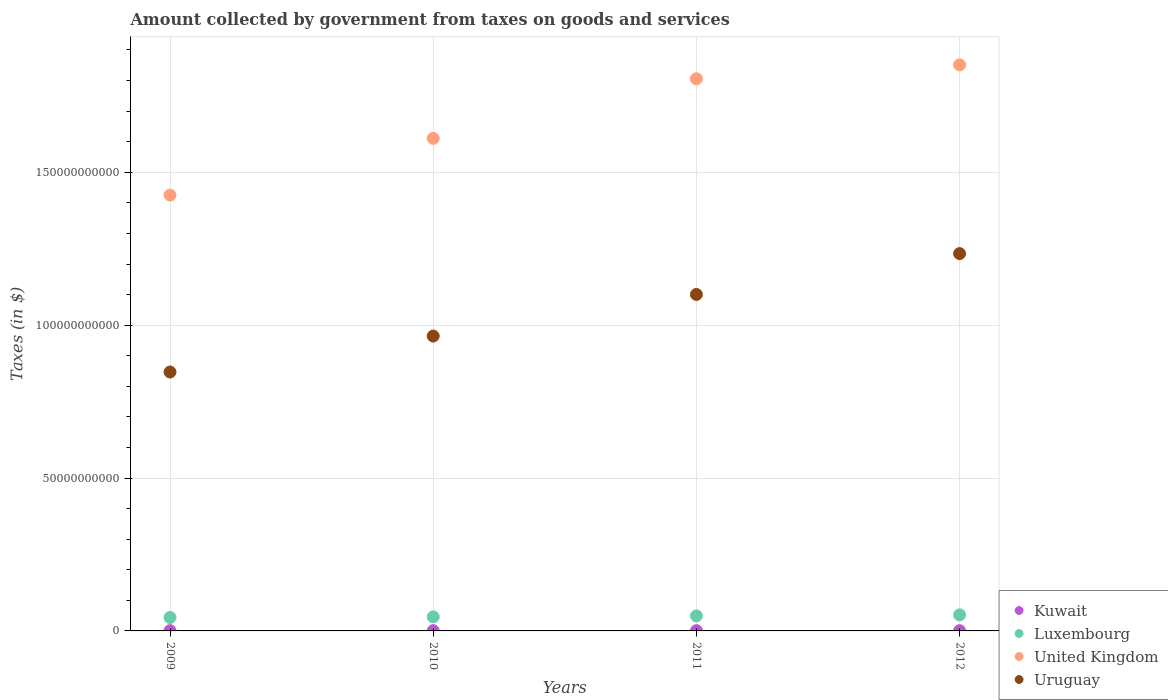What is the amount collected by government from taxes on goods and services in United Kingdom in 2011?
Make the answer very short. 1.81e+11. Across all years, what is the maximum amount collected by government from taxes on goods and services in Kuwait?
Offer a very short reply. 9.40e+07. Across all years, what is the minimum amount collected by government from taxes on goods and services in Kuwait?
Provide a short and direct response. 7.40e+07. In which year was the amount collected by government from taxes on goods and services in Luxembourg maximum?
Your response must be concise. 2012. In which year was the amount collected by government from taxes on goods and services in United Kingdom minimum?
Ensure brevity in your answer.  2009. What is the total amount collected by government from taxes on goods and services in United Kingdom in the graph?
Offer a terse response. 6.69e+11. What is the difference between the amount collected by government from taxes on goods and services in Uruguay in 2010 and that in 2012?
Your answer should be very brief. -2.70e+1. What is the difference between the amount collected by government from taxes on goods and services in Kuwait in 2011 and the amount collected by government from taxes on goods and services in United Kingdom in 2010?
Offer a terse response. -1.61e+11. What is the average amount collected by government from taxes on goods and services in Kuwait per year?
Provide a succinct answer. 8.55e+07. In the year 2009, what is the difference between the amount collected by government from taxes on goods and services in Kuwait and amount collected by government from taxes on goods and services in Uruguay?
Give a very brief answer. -8.46e+1. What is the ratio of the amount collected by government from taxes on goods and services in Luxembourg in 2009 to that in 2011?
Keep it short and to the point. 0.89. Is the amount collected by government from taxes on goods and services in Luxembourg in 2009 less than that in 2012?
Your response must be concise. Yes. What is the difference between the highest and the second highest amount collected by government from taxes on goods and services in Uruguay?
Your response must be concise. 1.34e+1. What is the difference between the highest and the lowest amount collected by government from taxes on goods and services in Luxembourg?
Provide a short and direct response. 8.72e+08. In how many years, is the amount collected by government from taxes on goods and services in Kuwait greater than the average amount collected by government from taxes on goods and services in Kuwait taken over all years?
Keep it short and to the point. 3. Is it the case that in every year, the sum of the amount collected by government from taxes on goods and services in Luxembourg and amount collected by government from taxes on goods and services in Kuwait  is greater than the amount collected by government from taxes on goods and services in United Kingdom?
Your answer should be very brief. No. Does the amount collected by government from taxes on goods and services in United Kingdom monotonically increase over the years?
Your response must be concise. Yes. Is the amount collected by government from taxes on goods and services in Kuwait strictly greater than the amount collected by government from taxes on goods and services in United Kingdom over the years?
Give a very brief answer. No. Is the amount collected by government from taxes on goods and services in Luxembourg strictly less than the amount collected by government from taxes on goods and services in Uruguay over the years?
Keep it short and to the point. Yes. How many dotlines are there?
Your response must be concise. 4. How many years are there in the graph?
Offer a very short reply. 4. What is the difference between two consecutive major ticks on the Y-axis?
Give a very brief answer. 5.00e+1. Are the values on the major ticks of Y-axis written in scientific E-notation?
Give a very brief answer. No. Does the graph contain any zero values?
Provide a succinct answer. No. Where does the legend appear in the graph?
Ensure brevity in your answer.  Bottom right. How are the legend labels stacked?
Keep it short and to the point. Vertical. What is the title of the graph?
Your response must be concise. Amount collected by government from taxes on goods and services. Does "Morocco" appear as one of the legend labels in the graph?
Offer a terse response. No. What is the label or title of the X-axis?
Your answer should be very brief. Years. What is the label or title of the Y-axis?
Your answer should be very brief. Taxes (in $). What is the Taxes (in $) in Kuwait in 2009?
Give a very brief answer. 9.40e+07. What is the Taxes (in $) of Luxembourg in 2009?
Make the answer very short. 4.38e+09. What is the Taxes (in $) of United Kingdom in 2009?
Your answer should be very brief. 1.43e+11. What is the Taxes (in $) in Uruguay in 2009?
Your response must be concise. 8.47e+1. What is the Taxes (in $) of Kuwait in 2010?
Keep it short and to the point. 8.80e+07. What is the Taxes (in $) in Luxembourg in 2010?
Your answer should be compact. 4.60e+09. What is the Taxes (in $) of United Kingdom in 2010?
Your answer should be compact. 1.61e+11. What is the Taxes (in $) in Uruguay in 2010?
Provide a succinct answer. 9.64e+1. What is the Taxes (in $) of Kuwait in 2011?
Give a very brief answer. 8.60e+07. What is the Taxes (in $) in Luxembourg in 2011?
Offer a very short reply. 4.92e+09. What is the Taxes (in $) in United Kingdom in 2011?
Your answer should be very brief. 1.81e+11. What is the Taxes (in $) in Uruguay in 2011?
Provide a short and direct response. 1.10e+11. What is the Taxes (in $) in Kuwait in 2012?
Ensure brevity in your answer.  7.40e+07. What is the Taxes (in $) in Luxembourg in 2012?
Your answer should be very brief. 5.25e+09. What is the Taxes (in $) in United Kingdom in 2012?
Your answer should be very brief. 1.85e+11. What is the Taxes (in $) of Uruguay in 2012?
Your answer should be very brief. 1.23e+11. Across all years, what is the maximum Taxes (in $) in Kuwait?
Make the answer very short. 9.40e+07. Across all years, what is the maximum Taxes (in $) in Luxembourg?
Make the answer very short. 5.25e+09. Across all years, what is the maximum Taxes (in $) in United Kingdom?
Your answer should be very brief. 1.85e+11. Across all years, what is the maximum Taxes (in $) in Uruguay?
Make the answer very short. 1.23e+11. Across all years, what is the minimum Taxes (in $) of Kuwait?
Provide a short and direct response. 7.40e+07. Across all years, what is the minimum Taxes (in $) of Luxembourg?
Your response must be concise. 4.38e+09. Across all years, what is the minimum Taxes (in $) of United Kingdom?
Your response must be concise. 1.43e+11. Across all years, what is the minimum Taxes (in $) in Uruguay?
Provide a succinct answer. 8.47e+1. What is the total Taxes (in $) of Kuwait in the graph?
Offer a terse response. 3.42e+08. What is the total Taxes (in $) in Luxembourg in the graph?
Offer a very short reply. 1.92e+1. What is the total Taxes (in $) of United Kingdom in the graph?
Keep it short and to the point. 6.69e+11. What is the total Taxes (in $) in Uruguay in the graph?
Give a very brief answer. 4.15e+11. What is the difference between the Taxes (in $) of Luxembourg in 2009 and that in 2010?
Your answer should be very brief. -2.15e+08. What is the difference between the Taxes (in $) in United Kingdom in 2009 and that in 2010?
Ensure brevity in your answer.  -1.86e+1. What is the difference between the Taxes (in $) of Uruguay in 2009 and that in 2010?
Your answer should be very brief. -1.18e+1. What is the difference between the Taxes (in $) in Luxembourg in 2009 and that in 2011?
Give a very brief answer. -5.37e+08. What is the difference between the Taxes (in $) of United Kingdom in 2009 and that in 2011?
Make the answer very short. -3.80e+1. What is the difference between the Taxes (in $) of Uruguay in 2009 and that in 2011?
Ensure brevity in your answer.  -2.54e+1. What is the difference between the Taxes (in $) in Kuwait in 2009 and that in 2012?
Ensure brevity in your answer.  2.00e+07. What is the difference between the Taxes (in $) in Luxembourg in 2009 and that in 2012?
Ensure brevity in your answer.  -8.72e+08. What is the difference between the Taxes (in $) in United Kingdom in 2009 and that in 2012?
Keep it short and to the point. -4.26e+1. What is the difference between the Taxes (in $) in Uruguay in 2009 and that in 2012?
Make the answer very short. -3.87e+1. What is the difference between the Taxes (in $) of Luxembourg in 2010 and that in 2011?
Offer a terse response. -3.22e+08. What is the difference between the Taxes (in $) in United Kingdom in 2010 and that in 2011?
Provide a succinct answer. -1.95e+1. What is the difference between the Taxes (in $) in Uruguay in 2010 and that in 2011?
Your response must be concise. -1.36e+1. What is the difference between the Taxes (in $) of Kuwait in 2010 and that in 2012?
Provide a short and direct response. 1.40e+07. What is the difference between the Taxes (in $) of Luxembourg in 2010 and that in 2012?
Your answer should be very brief. -6.56e+08. What is the difference between the Taxes (in $) in United Kingdom in 2010 and that in 2012?
Offer a terse response. -2.40e+1. What is the difference between the Taxes (in $) of Uruguay in 2010 and that in 2012?
Give a very brief answer. -2.70e+1. What is the difference between the Taxes (in $) in Kuwait in 2011 and that in 2012?
Offer a terse response. 1.20e+07. What is the difference between the Taxes (in $) of Luxembourg in 2011 and that in 2012?
Offer a very short reply. -3.35e+08. What is the difference between the Taxes (in $) of United Kingdom in 2011 and that in 2012?
Your answer should be compact. -4.55e+09. What is the difference between the Taxes (in $) of Uruguay in 2011 and that in 2012?
Provide a succinct answer. -1.34e+1. What is the difference between the Taxes (in $) of Kuwait in 2009 and the Taxes (in $) of Luxembourg in 2010?
Ensure brevity in your answer.  -4.50e+09. What is the difference between the Taxes (in $) in Kuwait in 2009 and the Taxes (in $) in United Kingdom in 2010?
Make the answer very short. -1.61e+11. What is the difference between the Taxes (in $) in Kuwait in 2009 and the Taxes (in $) in Uruguay in 2010?
Give a very brief answer. -9.63e+1. What is the difference between the Taxes (in $) of Luxembourg in 2009 and the Taxes (in $) of United Kingdom in 2010?
Your answer should be very brief. -1.57e+11. What is the difference between the Taxes (in $) of Luxembourg in 2009 and the Taxes (in $) of Uruguay in 2010?
Offer a terse response. -9.21e+1. What is the difference between the Taxes (in $) of United Kingdom in 2009 and the Taxes (in $) of Uruguay in 2010?
Your answer should be compact. 4.61e+1. What is the difference between the Taxes (in $) in Kuwait in 2009 and the Taxes (in $) in Luxembourg in 2011?
Your answer should be very brief. -4.83e+09. What is the difference between the Taxes (in $) in Kuwait in 2009 and the Taxes (in $) in United Kingdom in 2011?
Your response must be concise. -1.80e+11. What is the difference between the Taxes (in $) in Kuwait in 2009 and the Taxes (in $) in Uruguay in 2011?
Offer a very short reply. -1.10e+11. What is the difference between the Taxes (in $) of Luxembourg in 2009 and the Taxes (in $) of United Kingdom in 2011?
Your answer should be compact. -1.76e+11. What is the difference between the Taxes (in $) in Luxembourg in 2009 and the Taxes (in $) in Uruguay in 2011?
Provide a short and direct response. -1.06e+11. What is the difference between the Taxes (in $) of United Kingdom in 2009 and the Taxes (in $) of Uruguay in 2011?
Offer a very short reply. 3.25e+1. What is the difference between the Taxes (in $) in Kuwait in 2009 and the Taxes (in $) in Luxembourg in 2012?
Offer a terse response. -5.16e+09. What is the difference between the Taxes (in $) of Kuwait in 2009 and the Taxes (in $) of United Kingdom in 2012?
Your answer should be very brief. -1.85e+11. What is the difference between the Taxes (in $) in Kuwait in 2009 and the Taxes (in $) in Uruguay in 2012?
Your response must be concise. -1.23e+11. What is the difference between the Taxes (in $) in Luxembourg in 2009 and the Taxes (in $) in United Kingdom in 2012?
Offer a very short reply. -1.81e+11. What is the difference between the Taxes (in $) of Luxembourg in 2009 and the Taxes (in $) of Uruguay in 2012?
Your answer should be very brief. -1.19e+11. What is the difference between the Taxes (in $) of United Kingdom in 2009 and the Taxes (in $) of Uruguay in 2012?
Offer a terse response. 1.91e+1. What is the difference between the Taxes (in $) of Kuwait in 2010 and the Taxes (in $) of Luxembourg in 2011?
Offer a terse response. -4.83e+09. What is the difference between the Taxes (in $) of Kuwait in 2010 and the Taxes (in $) of United Kingdom in 2011?
Keep it short and to the point. -1.80e+11. What is the difference between the Taxes (in $) of Kuwait in 2010 and the Taxes (in $) of Uruguay in 2011?
Offer a very short reply. -1.10e+11. What is the difference between the Taxes (in $) in Luxembourg in 2010 and the Taxes (in $) in United Kingdom in 2011?
Provide a short and direct response. -1.76e+11. What is the difference between the Taxes (in $) in Luxembourg in 2010 and the Taxes (in $) in Uruguay in 2011?
Keep it short and to the point. -1.05e+11. What is the difference between the Taxes (in $) in United Kingdom in 2010 and the Taxes (in $) in Uruguay in 2011?
Offer a terse response. 5.10e+1. What is the difference between the Taxes (in $) of Kuwait in 2010 and the Taxes (in $) of Luxembourg in 2012?
Your answer should be very brief. -5.17e+09. What is the difference between the Taxes (in $) of Kuwait in 2010 and the Taxes (in $) of United Kingdom in 2012?
Your answer should be compact. -1.85e+11. What is the difference between the Taxes (in $) in Kuwait in 2010 and the Taxes (in $) in Uruguay in 2012?
Your answer should be compact. -1.23e+11. What is the difference between the Taxes (in $) of Luxembourg in 2010 and the Taxes (in $) of United Kingdom in 2012?
Your response must be concise. -1.81e+11. What is the difference between the Taxes (in $) of Luxembourg in 2010 and the Taxes (in $) of Uruguay in 2012?
Your answer should be compact. -1.19e+11. What is the difference between the Taxes (in $) of United Kingdom in 2010 and the Taxes (in $) of Uruguay in 2012?
Your answer should be very brief. 3.77e+1. What is the difference between the Taxes (in $) of Kuwait in 2011 and the Taxes (in $) of Luxembourg in 2012?
Provide a short and direct response. -5.17e+09. What is the difference between the Taxes (in $) of Kuwait in 2011 and the Taxes (in $) of United Kingdom in 2012?
Provide a short and direct response. -1.85e+11. What is the difference between the Taxes (in $) of Kuwait in 2011 and the Taxes (in $) of Uruguay in 2012?
Provide a short and direct response. -1.23e+11. What is the difference between the Taxes (in $) of Luxembourg in 2011 and the Taxes (in $) of United Kingdom in 2012?
Make the answer very short. -1.80e+11. What is the difference between the Taxes (in $) of Luxembourg in 2011 and the Taxes (in $) of Uruguay in 2012?
Your response must be concise. -1.18e+11. What is the difference between the Taxes (in $) of United Kingdom in 2011 and the Taxes (in $) of Uruguay in 2012?
Offer a terse response. 5.72e+1. What is the average Taxes (in $) of Kuwait per year?
Ensure brevity in your answer.  8.55e+07. What is the average Taxes (in $) of Luxembourg per year?
Provide a short and direct response. 4.79e+09. What is the average Taxes (in $) of United Kingdom per year?
Give a very brief answer. 1.67e+11. What is the average Taxes (in $) of Uruguay per year?
Make the answer very short. 1.04e+11. In the year 2009, what is the difference between the Taxes (in $) of Kuwait and Taxes (in $) of Luxembourg?
Keep it short and to the point. -4.29e+09. In the year 2009, what is the difference between the Taxes (in $) of Kuwait and Taxes (in $) of United Kingdom?
Provide a succinct answer. -1.42e+11. In the year 2009, what is the difference between the Taxes (in $) of Kuwait and Taxes (in $) of Uruguay?
Offer a very short reply. -8.46e+1. In the year 2009, what is the difference between the Taxes (in $) in Luxembourg and Taxes (in $) in United Kingdom?
Your answer should be very brief. -1.38e+11. In the year 2009, what is the difference between the Taxes (in $) of Luxembourg and Taxes (in $) of Uruguay?
Your answer should be very brief. -8.03e+1. In the year 2009, what is the difference between the Taxes (in $) in United Kingdom and Taxes (in $) in Uruguay?
Make the answer very short. 5.79e+1. In the year 2010, what is the difference between the Taxes (in $) in Kuwait and Taxes (in $) in Luxembourg?
Offer a terse response. -4.51e+09. In the year 2010, what is the difference between the Taxes (in $) of Kuwait and Taxes (in $) of United Kingdom?
Your answer should be very brief. -1.61e+11. In the year 2010, what is the difference between the Taxes (in $) of Kuwait and Taxes (in $) of Uruguay?
Give a very brief answer. -9.63e+1. In the year 2010, what is the difference between the Taxes (in $) in Luxembourg and Taxes (in $) in United Kingdom?
Give a very brief answer. -1.56e+11. In the year 2010, what is the difference between the Taxes (in $) of Luxembourg and Taxes (in $) of Uruguay?
Offer a terse response. -9.18e+1. In the year 2010, what is the difference between the Taxes (in $) in United Kingdom and Taxes (in $) in Uruguay?
Your response must be concise. 6.47e+1. In the year 2011, what is the difference between the Taxes (in $) in Kuwait and Taxes (in $) in Luxembourg?
Your answer should be very brief. -4.83e+09. In the year 2011, what is the difference between the Taxes (in $) of Kuwait and Taxes (in $) of United Kingdom?
Your response must be concise. -1.80e+11. In the year 2011, what is the difference between the Taxes (in $) of Kuwait and Taxes (in $) of Uruguay?
Provide a succinct answer. -1.10e+11. In the year 2011, what is the difference between the Taxes (in $) in Luxembourg and Taxes (in $) in United Kingdom?
Give a very brief answer. -1.76e+11. In the year 2011, what is the difference between the Taxes (in $) in Luxembourg and Taxes (in $) in Uruguay?
Your answer should be very brief. -1.05e+11. In the year 2011, what is the difference between the Taxes (in $) in United Kingdom and Taxes (in $) in Uruguay?
Keep it short and to the point. 7.05e+1. In the year 2012, what is the difference between the Taxes (in $) of Kuwait and Taxes (in $) of Luxembourg?
Your answer should be compact. -5.18e+09. In the year 2012, what is the difference between the Taxes (in $) of Kuwait and Taxes (in $) of United Kingdom?
Ensure brevity in your answer.  -1.85e+11. In the year 2012, what is the difference between the Taxes (in $) of Kuwait and Taxes (in $) of Uruguay?
Ensure brevity in your answer.  -1.23e+11. In the year 2012, what is the difference between the Taxes (in $) in Luxembourg and Taxes (in $) in United Kingdom?
Keep it short and to the point. -1.80e+11. In the year 2012, what is the difference between the Taxes (in $) in Luxembourg and Taxes (in $) in Uruguay?
Make the answer very short. -1.18e+11. In the year 2012, what is the difference between the Taxes (in $) of United Kingdom and Taxes (in $) of Uruguay?
Make the answer very short. 6.17e+1. What is the ratio of the Taxes (in $) in Kuwait in 2009 to that in 2010?
Make the answer very short. 1.07. What is the ratio of the Taxes (in $) of Luxembourg in 2009 to that in 2010?
Keep it short and to the point. 0.95. What is the ratio of the Taxes (in $) of United Kingdom in 2009 to that in 2010?
Provide a succinct answer. 0.88. What is the ratio of the Taxes (in $) in Uruguay in 2009 to that in 2010?
Offer a terse response. 0.88. What is the ratio of the Taxes (in $) of Kuwait in 2009 to that in 2011?
Give a very brief answer. 1.09. What is the ratio of the Taxes (in $) of Luxembourg in 2009 to that in 2011?
Offer a terse response. 0.89. What is the ratio of the Taxes (in $) of United Kingdom in 2009 to that in 2011?
Give a very brief answer. 0.79. What is the ratio of the Taxes (in $) of Uruguay in 2009 to that in 2011?
Ensure brevity in your answer.  0.77. What is the ratio of the Taxes (in $) of Kuwait in 2009 to that in 2012?
Offer a terse response. 1.27. What is the ratio of the Taxes (in $) in Luxembourg in 2009 to that in 2012?
Your answer should be very brief. 0.83. What is the ratio of the Taxes (in $) in United Kingdom in 2009 to that in 2012?
Give a very brief answer. 0.77. What is the ratio of the Taxes (in $) of Uruguay in 2009 to that in 2012?
Give a very brief answer. 0.69. What is the ratio of the Taxes (in $) of Kuwait in 2010 to that in 2011?
Provide a short and direct response. 1.02. What is the ratio of the Taxes (in $) of Luxembourg in 2010 to that in 2011?
Your answer should be compact. 0.93. What is the ratio of the Taxes (in $) of United Kingdom in 2010 to that in 2011?
Your response must be concise. 0.89. What is the ratio of the Taxes (in $) in Uruguay in 2010 to that in 2011?
Offer a very short reply. 0.88. What is the ratio of the Taxes (in $) of Kuwait in 2010 to that in 2012?
Keep it short and to the point. 1.19. What is the ratio of the Taxes (in $) of Luxembourg in 2010 to that in 2012?
Provide a succinct answer. 0.88. What is the ratio of the Taxes (in $) of United Kingdom in 2010 to that in 2012?
Your response must be concise. 0.87. What is the ratio of the Taxes (in $) in Uruguay in 2010 to that in 2012?
Your answer should be very brief. 0.78. What is the ratio of the Taxes (in $) of Kuwait in 2011 to that in 2012?
Your answer should be very brief. 1.16. What is the ratio of the Taxes (in $) in Luxembourg in 2011 to that in 2012?
Ensure brevity in your answer.  0.94. What is the ratio of the Taxes (in $) of United Kingdom in 2011 to that in 2012?
Give a very brief answer. 0.98. What is the ratio of the Taxes (in $) in Uruguay in 2011 to that in 2012?
Keep it short and to the point. 0.89. What is the difference between the highest and the second highest Taxes (in $) of Luxembourg?
Your answer should be very brief. 3.35e+08. What is the difference between the highest and the second highest Taxes (in $) of United Kingdom?
Your answer should be very brief. 4.55e+09. What is the difference between the highest and the second highest Taxes (in $) in Uruguay?
Your answer should be compact. 1.34e+1. What is the difference between the highest and the lowest Taxes (in $) of Luxembourg?
Your answer should be compact. 8.72e+08. What is the difference between the highest and the lowest Taxes (in $) in United Kingdom?
Provide a succinct answer. 4.26e+1. What is the difference between the highest and the lowest Taxes (in $) in Uruguay?
Give a very brief answer. 3.87e+1. 